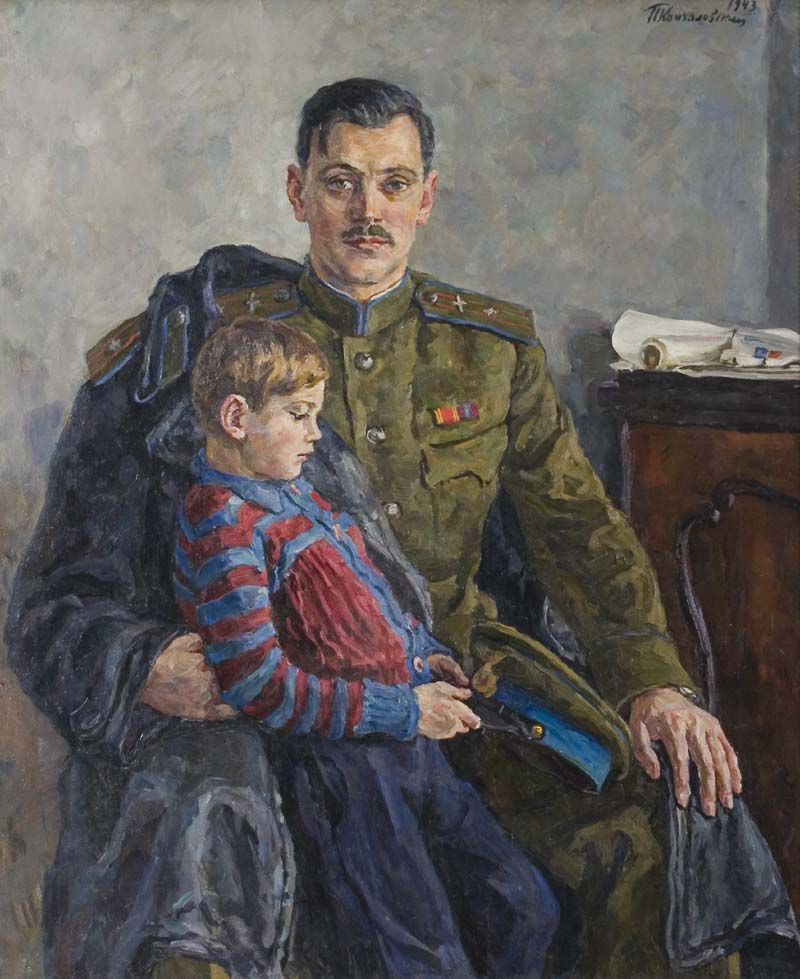What is this photo about? The painting captures a poignant moment featuring a man in a military uniform and a young boy, likely his son, set against a subdued background. The officer, dressed in a distinguished green uniform with a red-striped collar and a medal, exudes a sense of duty and pride. The boy, wearing a vibrant red and blue striped shirt, adds a touch of innocence and contrasts sharply with the seriousness of the military uniform. The artwork, signed 'Theo van Rysselberghe 1913', is a brilliant example of Impressionist style, where the emotionally charged subjects are rendered with loosened brushstrokes and a muted palette, emphasizing the intimacy and tender connection between the father and son amidst the broader context of military life. 